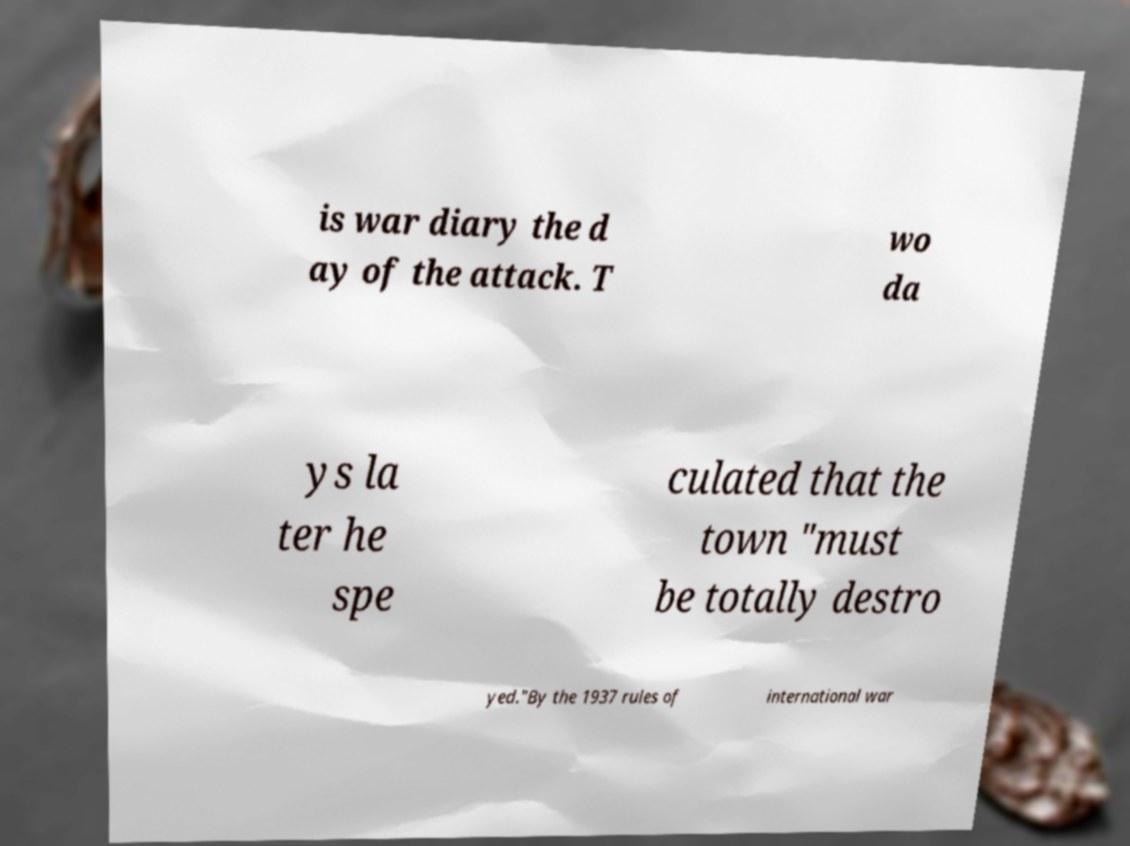Could you extract and type out the text from this image? is war diary the d ay of the attack. T wo da ys la ter he spe culated that the town "must be totally destro yed."By the 1937 rules of international war 